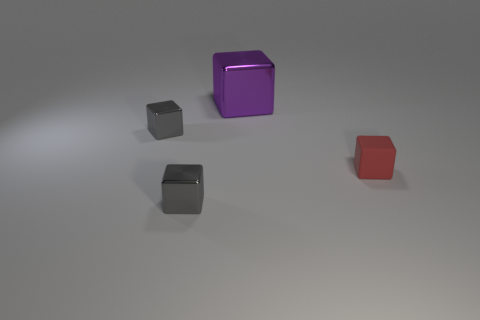What is the size of the red matte object that is the same shape as the large purple thing?
Offer a very short reply. Small. The metallic thing that is behind the gray thing behind the object that is right of the large purple cube is what color?
Offer a very short reply. Purple. Is the large purple object made of the same material as the red cube?
Make the answer very short. No. Are there any metal objects behind the gray block behind the object that is on the right side of the large metallic thing?
Provide a succinct answer. Yes. Is the large metal block the same color as the tiny rubber cube?
Offer a terse response. No. Are there fewer big red metal cylinders than big purple metallic objects?
Provide a short and direct response. Yes. Does the tiny thing that is on the right side of the purple block have the same material as the gray object that is in front of the tiny red thing?
Keep it short and to the point. No. Are there fewer gray shiny blocks behind the big purple cube than large red shiny cubes?
Ensure brevity in your answer.  No. There is a tiny cube that is on the right side of the purple shiny cube; how many gray metallic blocks are to the right of it?
Make the answer very short. 0. What size is the metallic thing that is both in front of the large purple thing and behind the tiny rubber thing?
Your response must be concise. Small. 